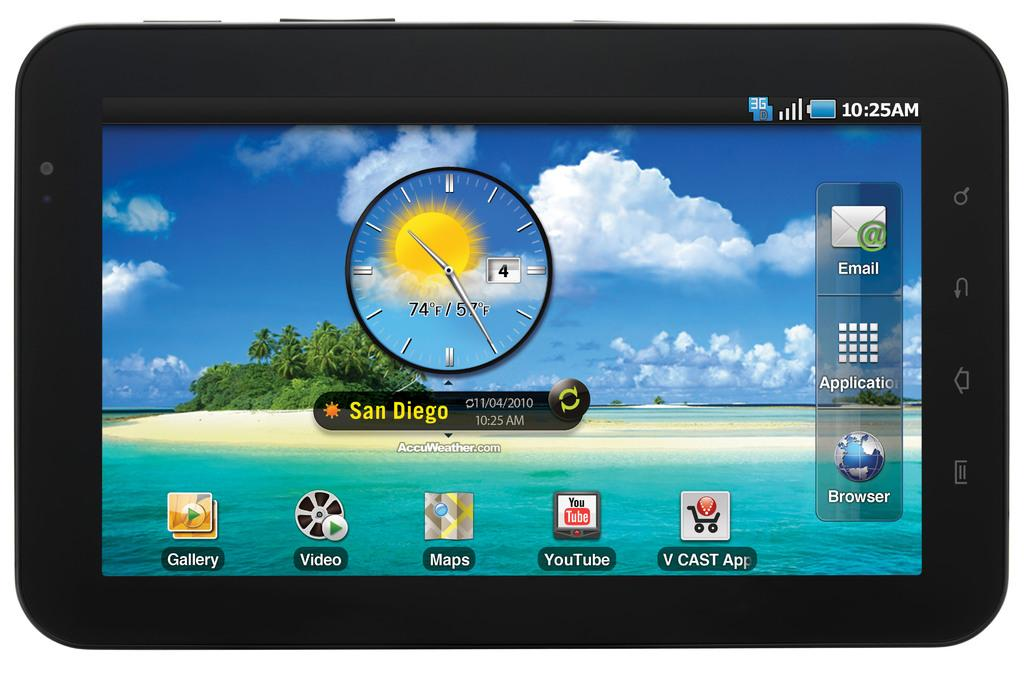Provide a one-sentence caption for the provided image. the city of san diego which is on a screen. 